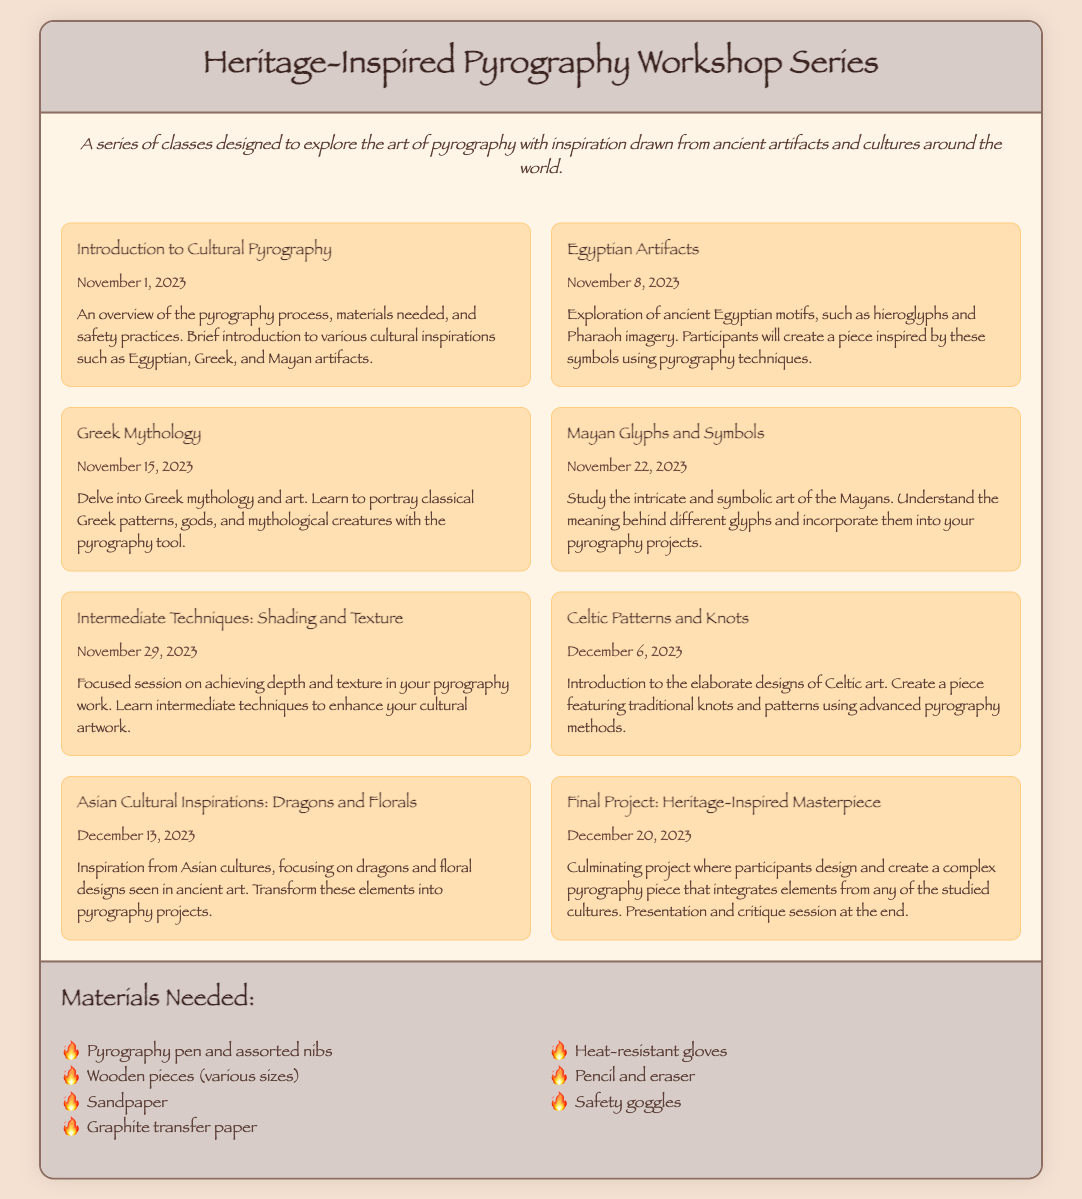What is the title of the workshop series? The title is displayed prominently at the top of the document and is "Heritage-Inspired Pyrography Workshop Series."
Answer: Heritage-Inspired Pyrography Workshop Series When is the "Greek Mythology" workshop scheduled? The date for the "Greek Mythology" workshop is provided in the event details.
Answer: November 15, 2023 How many workshops are there in total? The total number of workshops is calculated by counting each event listed in the calendar.
Answer: 8 What is required for safety during the workshops? The materials list includes safety gear that protects participants during the pyrography work.
Answer: Safety goggles What ancient culture is explored on November 22, 2023? The document mentions a specific cultural exploration on that date, focusing on ancient symbolism.
Answer: Mayan Which workshop focuses on shading and texture techniques? The calendar lists a specific workshop emphasizing these skills, which is categorized with intermediate techniques.
Answer: Intermediate Techniques: Shading and Texture What is the final project about? The description for the final workshop outlines the culmination of the series, focusing on integrating cultures into artwork.
Answer: Heritage-Inspired Masterpiece What materials are needed for the workshops? The workshops require a set of tools and materials, listed towards the end of the document.
Answer: Pyrography pen and assorted nibs 